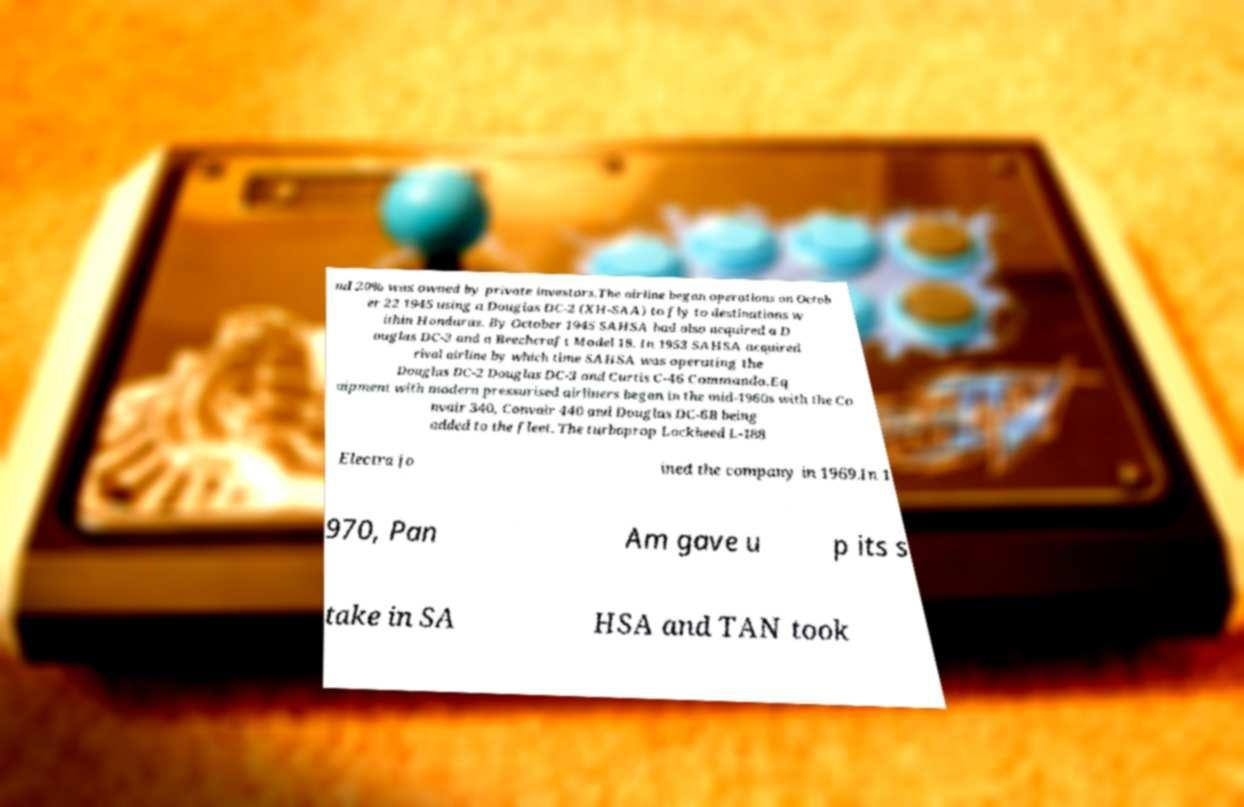Please identify and transcribe the text found in this image. nd 20% was owned by private investors.The airline began operations on Octob er 22 1945 using a Douglas DC-2 (XH-SAA) to fly to destinations w ithin Honduras. By October 1945 SAHSA had also acquired a D ouglas DC-3 and a Beechcraft Model 18. In 1953 SAHSA acquired rival airline by which time SAHSA was operating the Douglas DC-2 Douglas DC-3 and Curtis C-46 Commando.Eq uipment with modern pressurised airliners began in the mid-1960s with the Co nvair 340, Convair 440 and Douglas DC-6B being added to the fleet. The turboprop Lockheed L-188 Electra jo ined the company in 1969.In 1 970, Pan Am gave u p its s take in SA HSA and TAN took 